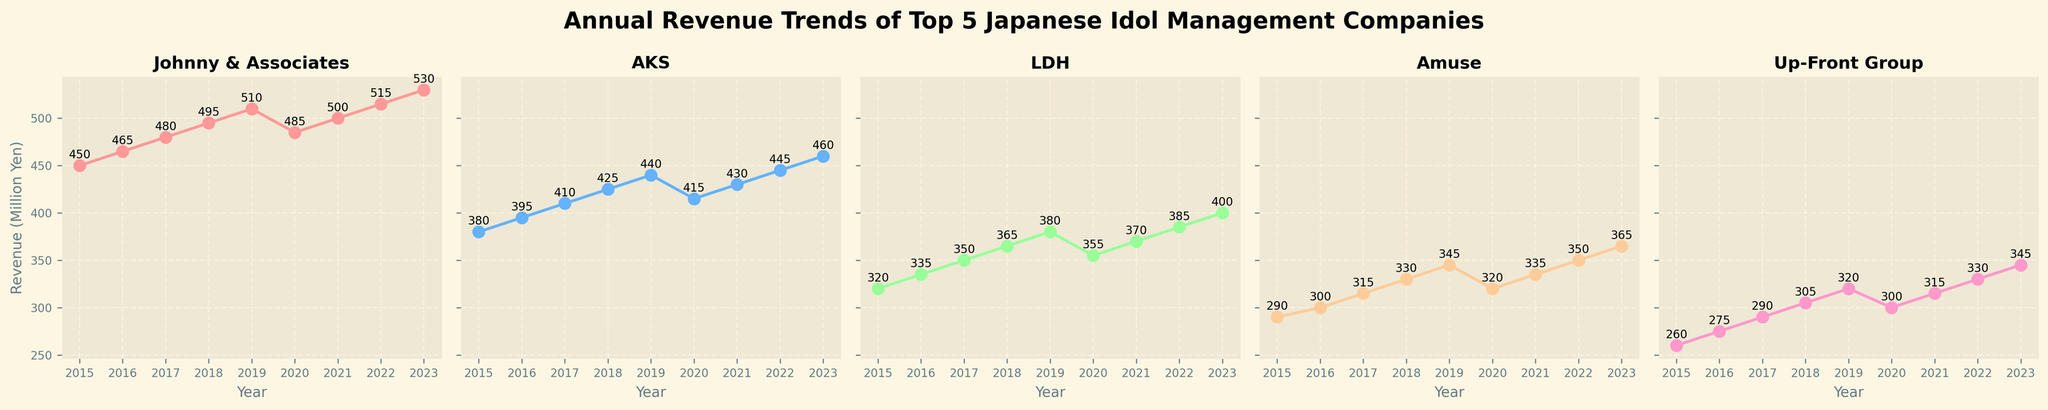Which company had the highest revenue in 2018? In 2018, Johnny & Associates had the highest revenue as indicated by its highest position on the subplot.
Answer: Johnny & Associates How did AKS's revenue change from 2020 to 2021? From 2020 to 2021, AKS’s revenue increased, going from 415 million yen to 430 million yen.
Answer: Increased Compare the revenue of LDH and Amuse in 2023. Which company had higher revenue? In 2023, LDH's revenue was 400 million yen, while Amuse's revenue was 365 million yen. Therefore, LDH had higher revenue.
Answer: LDH Which company's revenue dipped in 2020 compared to 2019? The subplot for Johnny & Associates shows a decrease from 510 million yen in 2019 to 485 million yen in 2020.
Answer: Johnny & Associates What is the average revenue of Up-Front Group from 2015 to 2023? The revenues are: 260, 275, 290, 305, 320, 300, 315, 330, 345. The sum is 2740; the number of years is 9. The average is 2740/9 ≈ 304.44 million yen.
Answer: 304.44 million yen What is the total revenue of Amuse over the years 2017, 2018, and 2019? The revenues for Amuse in the given years are 315, 330, and 345 million yen. Sum them up: 315 + 330 + 345 = 990 million yen
Answer: 990 million yen Did any company have a continuous increase in revenue from 2015 to 2023 without any dips? All companies' subplots must be examined to verify this. Johnny & Associates' revenue dipped in 2020; the same applies to other companies which experienced a dip or stable revenue in certain years. No company had a continuous rise.
Answer: No Which company had the smallest revenue in 2021 and how much was it? The subplot for Up-Front Group shows the smallest revenue in 2021 at 315 million yen.
Answer: Up-Front Group, 315 million yen 